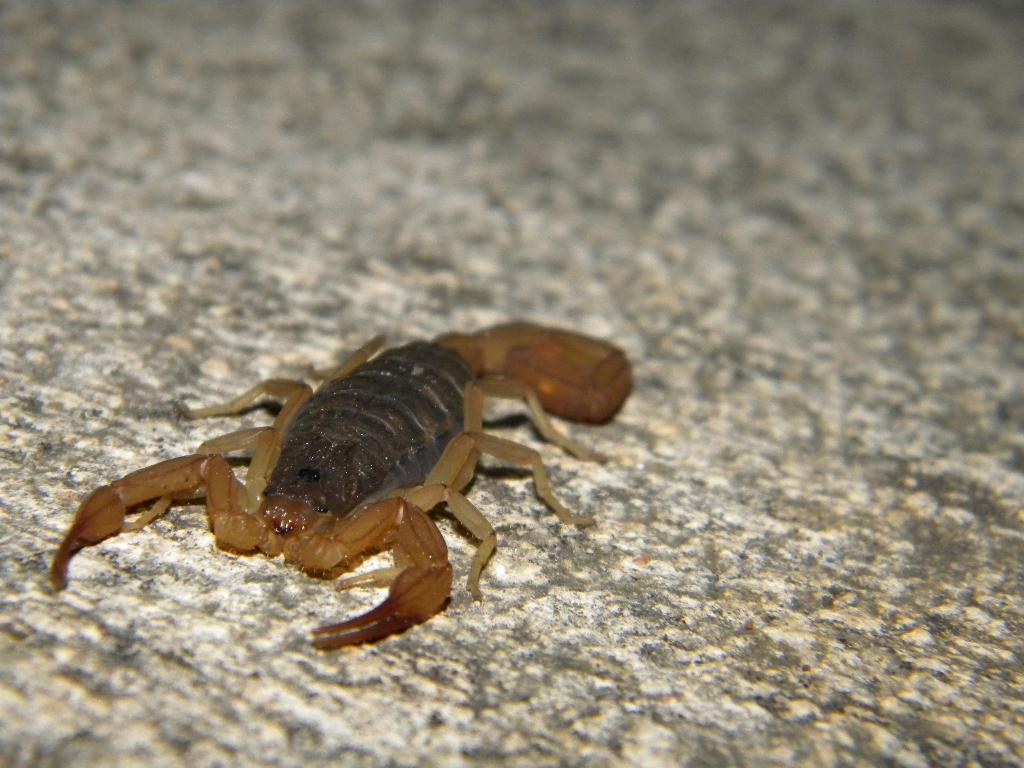What type of animal is present in the image? There is a scorpion in the image. What type of waste is visible in the image? There is no waste present in the image; it only features a scorpion. Can you describe the chair in the image? There is no chair present in the image; it only features a scorpion. 